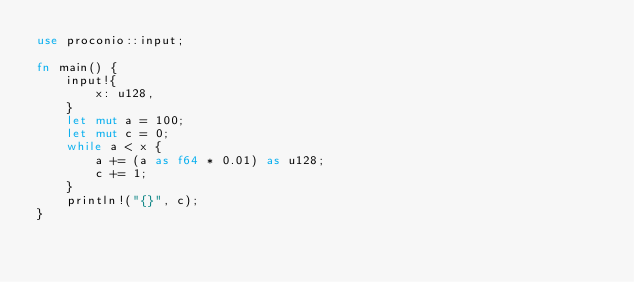<code> <loc_0><loc_0><loc_500><loc_500><_Rust_>use proconio::input;

fn main() {
    input!{
        x: u128,
    }
    let mut a = 100;
    let mut c = 0;
    while a < x {
        a += (a as f64 * 0.01) as u128;
        c += 1;
    }
    println!("{}", c);
}
</code> 